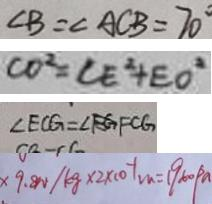Convert formula to latex. <formula><loc_0><loc_0><loc_500><loc_500>\angle B = \angle A C B = 7 0 ^ { \circ } 
 C O ^ { 2 } = C E ^ { 2 } + E O ^ { 2 } 
 \angle E C G = \angle F C G 
 \times 9 . 8 N / k g \times 2 \times 1 0 ^ { - 1 } m = 1 9 6 0 p a</formula> 